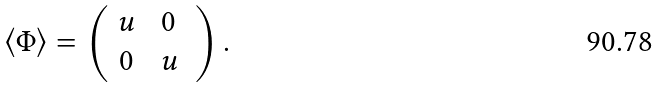Convert formula to latex. <formula><loc_0><loc_0><loc_500><loc_500>\langle \Phi \rangle = \left ( \begin{array} { c c } u \ & 0 \ \\ 0 \ & u \ \end{array} \right ) .</formula> 